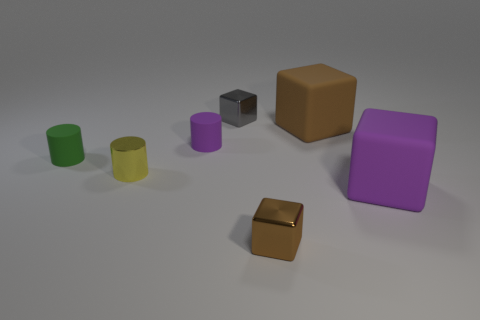There is a shiny thing that is right of the small cube that is behind the large purple matte object; what size is it?
Provide a short and direct response. Small. There is a green thing that is the same shape as the yellow object; what material is it?
Offer a terse response. Rubber. Is the color of the shiny object to the left of the gray shiny cube the same as the rubber cylinder that is to the left of the tiny purple object?
Offer a very short reply. No. Are there fewer shiny cylinders right of the brown metal block than purple matte cylinders that are on the left side of the big brown matte block?
Give a very brief answer. Yes. The large thing in front of the purple matte cylinder has what shape?
Ensure brevity in your answer.  Cube. How many other things are there of the same material as the small yellow cylinder?
Offer a terse response. 2. There is a tiny brown object; does it have the same shape as the tiny shiny thing that is behind the tiny yellow object?
Provide a succinct answer. Yes. What is the shape of the gray thing that is the same material as the yellow cylinder?
Offer a very short reply. Cube. Are there more tiny metal cubes that are in front of the big brown thing than small brown metallic cubes that are behind the purple rubber block?
Ensure brevity in your answer.  Yes. How many objects are tiny metal blocks or large cubes?
Your response must be concise. 4. 